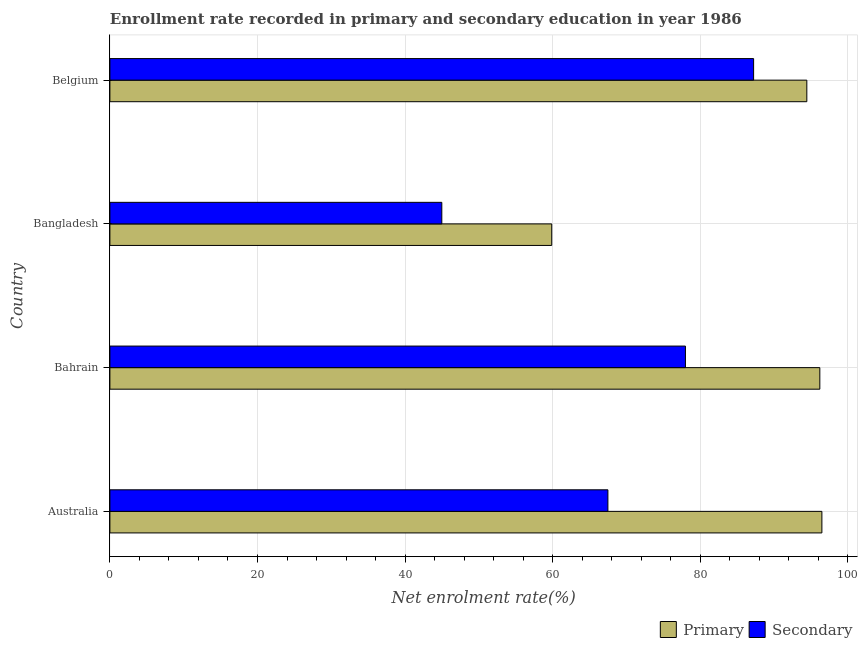How many different coloured bars are there?
Ensure brevity in your answer.  2. Are the number of bars per tick equal to the number of legend labels?
Offer a terse response. Yes. How many bars are there on the 1st tick from the top?
Keep it short and to the point. 2. What is the label of the 1st group of bars from the top?
Your answer should be compact. Belgium. What is the enrollment rate in secondary education in Bangladesh?
Your answer should be compact. 44.98. Across all countries, what is the maximum enrollment rate in secondary education?
Offer a very short reply. 87.23. Across all countries, what is the minimum enrollment rate in primary education?
Your answer should be very brief. 59.87. In which country was the enrollment rate in secondary education minimum?
Your answer should be very brief. Bangladesh. What is the total enrollment rate in primary education in the graph?
Offer a very short reply. 347. What is the difference between the enrollment rate in secondary education in Australia and that in Bangladesh?
Offer a very short reply. 22.51. What is the difference between the enrollment rate in primary education in Bangladesh and the enrollment rate in secondary education in Bahrain?
Make the answer very short. -18.12. What is the average enrollment rate in secondary education per country?
Provide a short and direct response. 69.42. What is the difference between the enrollment rate in secondary education and enrollment rate in primary education in Australia?
Offer a very short reply. -29. What is the ratio of the enrollment rate in primary education in Australia to that in Bangladesh?
Offer a terse response. 1.61. What is the difference between the highest and the second highest enrollment rate in primary education?
Ensure brevity in your answer.  0.28. What is the difference between the highest and the lowest enrollment rate in secondary education?
Your answer should be compact. 42.25. In how many countries, is the enrollment rate in secondary education greater than the average enrollment rate in secondary education taken over all countries?
Offer a terse response. 2. Is the sum of the enrollment rate in primary education in Australia and Bahrain greater than the maximum enrollment rate in secondary education across all countries?
Your answer should be very brief. Yes. What does the 1st bar from the top in Australia represents?
Offer a very short reply. Secondary. What does the 2nd bar from the bottom in Australia represents?
Your response must be concise. Secondary. How many bars are there?
Keep it short and to the point. 8. Are all the bars in the graph horizontal?
Your answer should be compact. Yes. How many countries are there in the graph?
Make the answer very short. 4. Are the values on the major ticks of X-axis written in scientific E-notation?
Make the answer very short. No. Does the graph contain any zero values?
Give a very brief answer. No. Does the graph contain grids?
Provide a short and direct response. Yes. What is the title of the graph?
Make the answer very short. Enrollment rate recorded in primary and secondary education in year 1986. What is the label or title of the X-axis?
Provide a succinct answer. Net enrolment rate(%). What is the label or title of the Y-axis?
Your response must be concise. Country. What is the Net enrolment rate(%) of Primary in Australia?
Provide a succinct answer. 96.48. What is the Net enrolment rate(%) in Secondary in Australia?
Provide a succinct answer. 67.49. What is the Net enrolment rate(%) of Primary in Bahrain?
Your answer should be compact. 96.2. What is the Net enrolment rate(%) in Secondary in Bahrain?
Give a very brief answer. 77.99. What is the Net enrolment rate(%) of Primary in Bangladesh?
Your answer should be very brief. 59.87. What is the Net enrolment rate(%) of Secondary in Bangladesh?
Offer a terse response. 44.98. What is the Net enrolment rate(%) in Primary in Belgium?
Give a very brief answer. 94.44. What is the Net enrolment rate(%) in Secondary in Belgium?
Provide a short and direct response. 87.23. Across all countries, what is the maximum Net enrolment rate(%) of Primary?
Your answer should be compact. 96.48. Across all countries, what is the maximum Net enrolment rate(%) in Secondary?
Your response must be concise. 87.23. Across all countries, what is the minimum Net enrolment rate(%) in Primary?
Offer a very short reply. 59.87. Across all countries, what is the minimum Net enrolment rate(%) in Secondary?
Offer a terse response. 44.98. What is the total Net enrolment rate(%) in Primary in the graph?
Make the answer very short. 347. What is the total Net enrolment rate(%) in Secondary in the graph?
Offer a terse response. 277.69. What is the difference between the Net enrolment rate(%) in Primary in Australia and that in Bahrain?
Provide a short and direct response. 0.28. What is the difference between the Net enrolment rate(%) in Secondary in Australia and that in Bahrain?
Your response must be concise. -10.51. What is the difference between the Net enrolment rate(%) in Primary in Australia and that in Bangladesh?
Give a very brief answer. 36.61. What is the difference between the Net enrolment rate(%) of Secondary in Australia and that in Bangladesh?
Give a very brief answer. 22.51. What is the difference between the Net enrolment rate(%) in Primary in Australia and that in Belgium?
Your answer should be compact. 2.04. What is the difference between the Net enrolment rate(%) of Secondary in Australia and that in Belgium?
Your response must be concise. -19.74. What is the difference between the Net enrolment rate(%) of Primary in Bahrain and that in Bangladesh?
Keep it short and to the point. 36.33. What is the difference between the Net enrolment rate(%) in Secondary in Bahrain and that in Bangladesh?
Make the answer very short. 33.02. What is the difference between the Net enrolment rate(%) of Primary in Bahrain and that in Belgium?
Your answer should be very brief. 1.76. What is the difference between the Net enrolment rate(%) in Secondary in Bahrain and that in Belgium?
Keep it short and to the point. -9.24. What is the difference between the Net enrolment rate(%) of Primary in Bangladesh and that in Belgium?
Give a very brief answer. -34.57. What is the difference between the Net enrolment rate(%) in Secondary in Bangladesh and that in Belgium?
Give a very brief answer. -42.25. What is the difference between the Net enrolment rate(%) in Primary in Australia and the Net enrolment rate(%) in Secondary in Bahrain?
Offer a very short reply. 18.49. What is the difference between the Net enrolment rate(%) of Primary in Australia and the Net enrolment rate(%) of Secondary in Bangladesh?
Offer a very short reply. 51.51. What is the difference between the Net enrolment rate(%) in Primary in Australia and the Net enrolment rate(%) in Secondary in Belgium?
Your answer should be very brief. 9.25. What is the difference between the Net enrolment rate(%) in Primary in Bahrain and the Net enrolment rate(%) in Secondary in Bangladesh?
Your answer should be compact. 51.23. What is the difference between the Net enrolment rate(%) of Primary in Bahrain and the Net enrolment rate(%) of Secondary in Belgium?
Ensure brevity in your answer.  8.97. What is the difference between the Net enrolment rate(%) in Primary in Bangladesh and the Net enrolment rate(%) in Secondary in Belgium?
Offer a terse response. -27.36. What is the average Net enrolment rate(%) in Primary per country?
Provide a succinct answer. 86.75. What is the average Net enrolment rate(%) of Secondary per country?
Provide a succinct answer. 69.42. What is the difference between the Net enrolment rate(%) in Primary and Net enrolment rate(%) in Secondary in Australia?
Offer a very short reply. 29. What is the difference between the Net enrolment rate(%) in Primary and Net enrolment rate(%) in Secondary in Bahrain?
Provide a short and direct response. 18.21. What is the difference between the Net enrolment rate(%) in Primary and Net enrolment rate(%) in Secondary in Bangladesh?
Provide a succinct answer. 14.9. What is the difference between the Net enrolment rate(%) in Primary and Net enrolment rate(%) in Secondary in Belgium?
Give a very brief answer. 7.21. What is the ratio of the Net enrolment rate(%) of Secondary in Australia to that in Bahrain?
Ensure brevity in your answer.  0.87. What is the ratio of the Net enrolment rate(%) in Primary in Australia to that in Bangladesh?
Make the answer very short. 1.61. What is the ratio of the Net enrolment rate(%) in Secondary in Australia to that in Bangladesh?
Make the answer very short. 1.5. What is the ratio of the Net enrolment rate(%) in Primary in Australia to that in Belgium?
Provide a succinct answer. 1.02. What is the ratio of the Net enrolment rate(%) of Secondary in Australia to that in Belgium?
Keep it short and to the point. 0.77. What is the ratio of the Net enrolment rate(%) in Primary in Bahrain to that in Bangladesh?
Keep it short and to the point. 1.61. What is the ratio of the Net enrolment rate(%) in Secondary in Bahrain to that in Bangladesh?
Offer a very short reply. 1.73. What is the ratio of the Net enrolment rate(%) in Primary in Bahrain to that in Belgium?
Make the answer very short. 1.02. What is the ratio of the Net enrolment rate(%) of Secondary in Bahrain to that in Belgium?
Your response must be concise. 0.89. What is the ratio of the Net enrolment rate(%) in Primary in Bangladesh to that in Belgium?
Your answer should be very brief. 0.63. What is the ratio of the Net enrolment rate(%) of Secondary in Bangladesh to that in Belgium?
Keep it short and to the point. 0.52. What is the difference between the highest and the second highest Net enrolment rate(%) in Primary?
Offer a terse response. 0.28. What is the difference between the highest and the second highest Net enrolment rate(%) of Secondary?
Your answer should be very brief. 9.24. What is the difference between the highest and the lowest Net enrolment rate(%) in Primary?
Your answer should be very brief. 36.61. What is the difference between the highest and the lowest Net enrolment rate(%) in Secondary?
Keep it short and to the point. 42.25. 